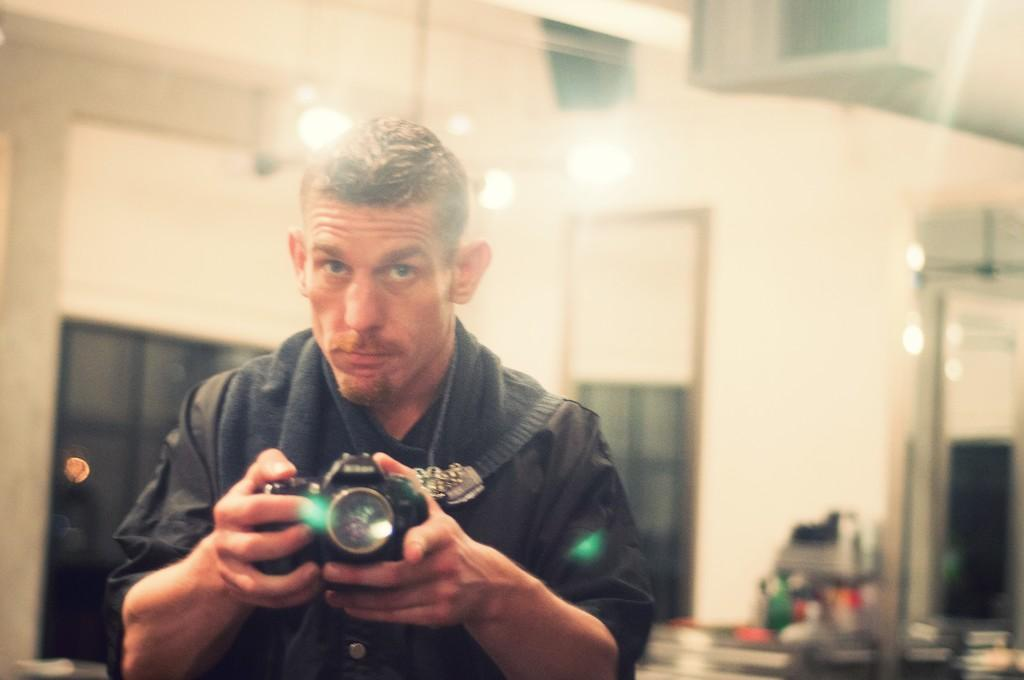Who is present in the image? There is a man in the image. What is the man wearing? The man is wearing a black shirt. What is the man holding in the image? The man is holding a camera. What can be seen in the background of the image? There is a window in the background of the image. What is visible through the window? There is a wall visible through the window. What type of insurance policy does the man have for his camera in the image? There is no information about the man's insurance policy for his camera in the image. 